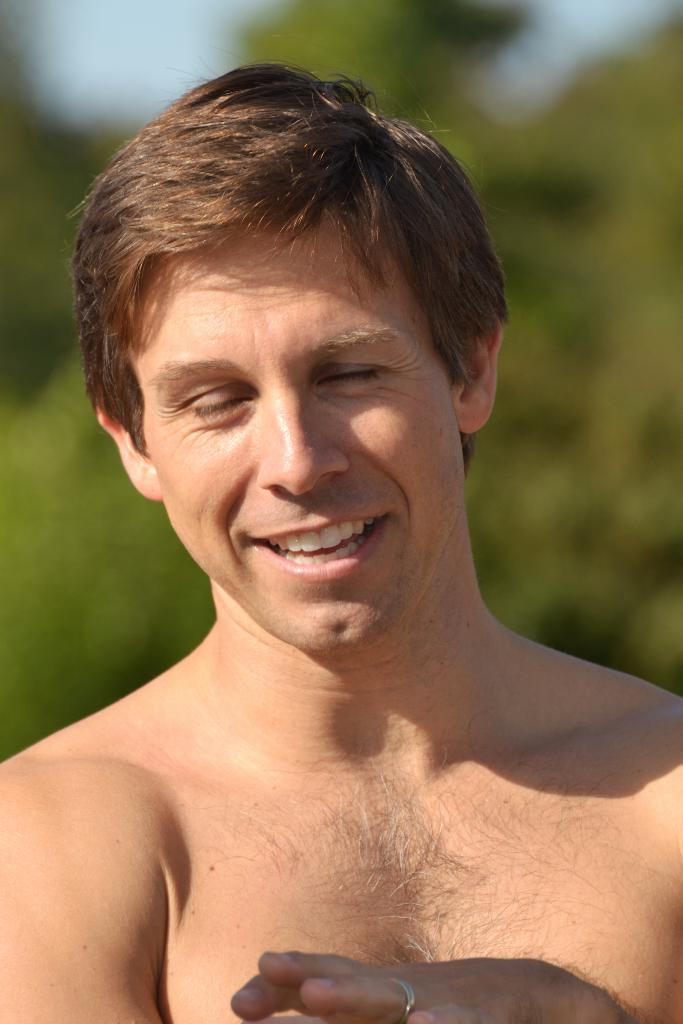Who is present in the image? There is a man in the image. What expression does the man have? The man is smiling. What can be seen in the background of the image? There appears to be a tree in the background of the image. How would you describe the background of the image? The background of the image is blurry. What type of beds can be seen in the image? There are no beds present in the image. What range of motion does the man have in the image? The image does not show the man in motion, so it is not possible to determine his range of motion. 